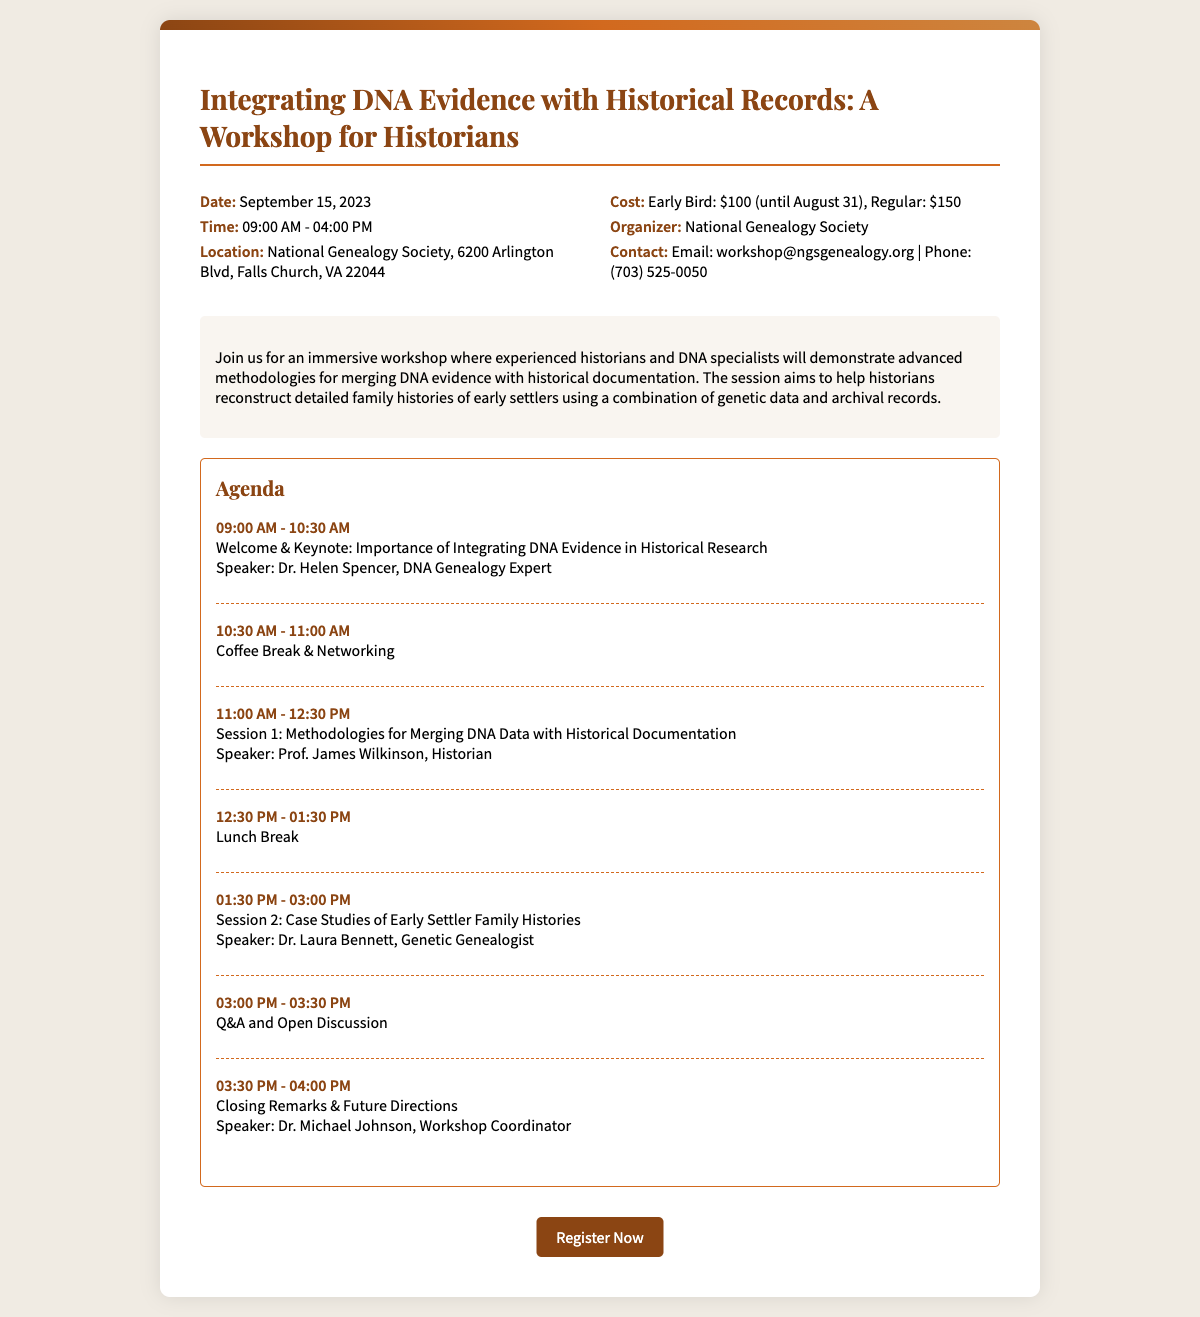What is the date of the workshop? The workshop is scheduled for September 15, 2023, as stated in the document.
Answer: September 15, 2023 What is the location of the workshop? The document mentions the workshop will be held at the National Genealogy Society in Falls Church, VA.
Answer: National Genealogy Society, Falls Church, VA What is the cost for regular registration? The document lists the regular cost as $150 for the workshop.
Answer: $150 Who is the speaker for the keynote session? The document identifies Dr. Helen Spencer as the speaker for the keynote session.
Answer: Dr. Helen Spencer What is covered in Session 2 of the agenda? According to the agenda section, Session 2 focuses on case studies of early settler family histories.
Answer: Case Studies of Early Settler Family Histories How long is the coffee break? The document specifies the coffee break as lasting for 30 minutes.
Answer: 30 minutes What time does the workshop start? The document states that the workshop starts at 09:00 AM.
Answer: 09:00 AM What type of event is described in the document? The document is about a workshop aimed at merging DNA evidence with historical records.
Answer: Workshop 